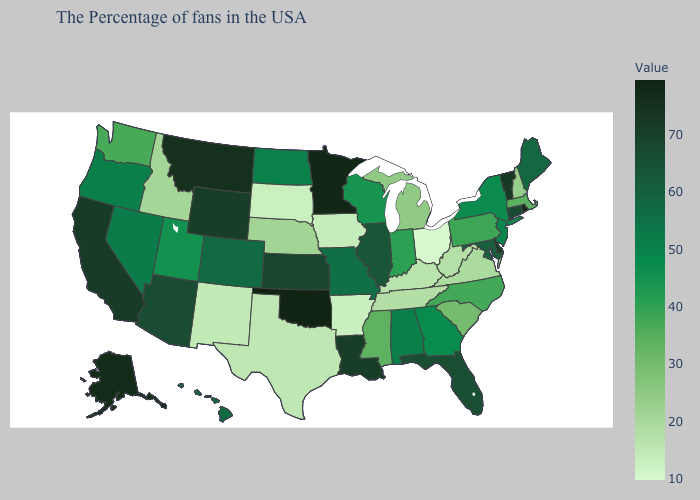Among the states that border Iowa , does Minnesota have the lowest value?
Keep it brief. No. Which states have the highest value in the USA?
Concise answer only. Oklahoma. Is the legend a continuous bar?
Concise answer only. Yes. Which states hav the highest value in the Northeast?
Quick response, please. Rhode Island. Does the map have missing data?
Give a very brief answer. No. Which states have the highest value in the USA?
Keep it brief. Oklahoma. Does Vermont have the lowest value in the Northeast?
Concise answer only. No. Is the legend a continuous bar?
Be succinct. Yes. 